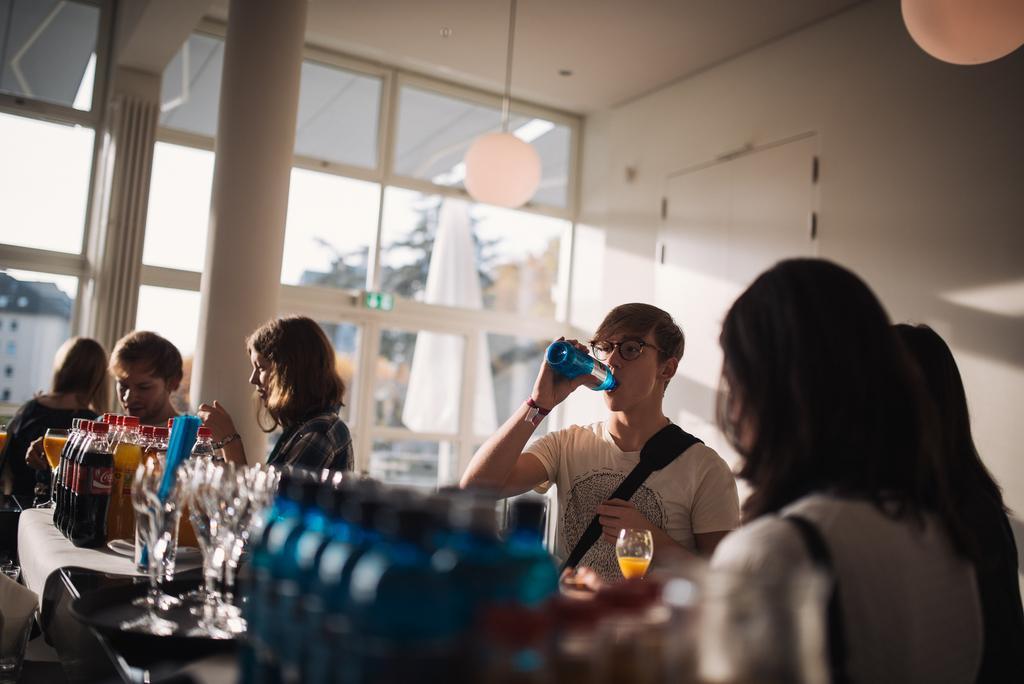Please provide a concise description of this image. Man standing in the middle and having drink with his hand in the right two women are standing at here and also in the left few persons are standing near the coke and fruit bottles in the middle there is a glass wall and there are balloons at the top. 